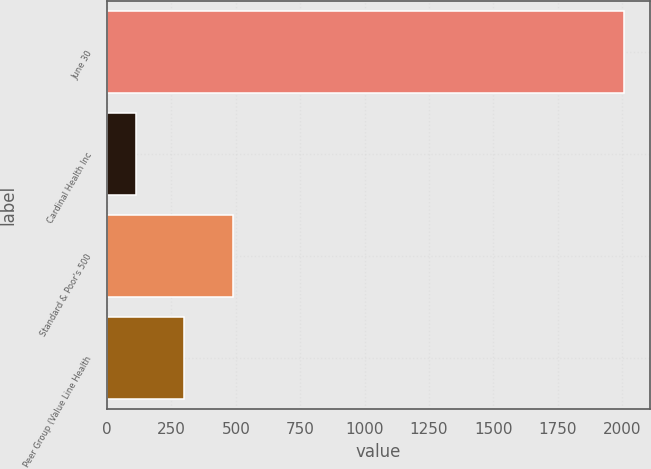<chart> <loc_0><loc_0><loc_500><loc_500><bar_chart><fcel>June 30<fcel>Cardinal Health Inc<fcel>Standard & Poor's 500<fcel>Peer Group (Value Line Health<nl><fcel>2007<fcel>110.44<fcel>489.76<fcel>300.1<nl></chart> 